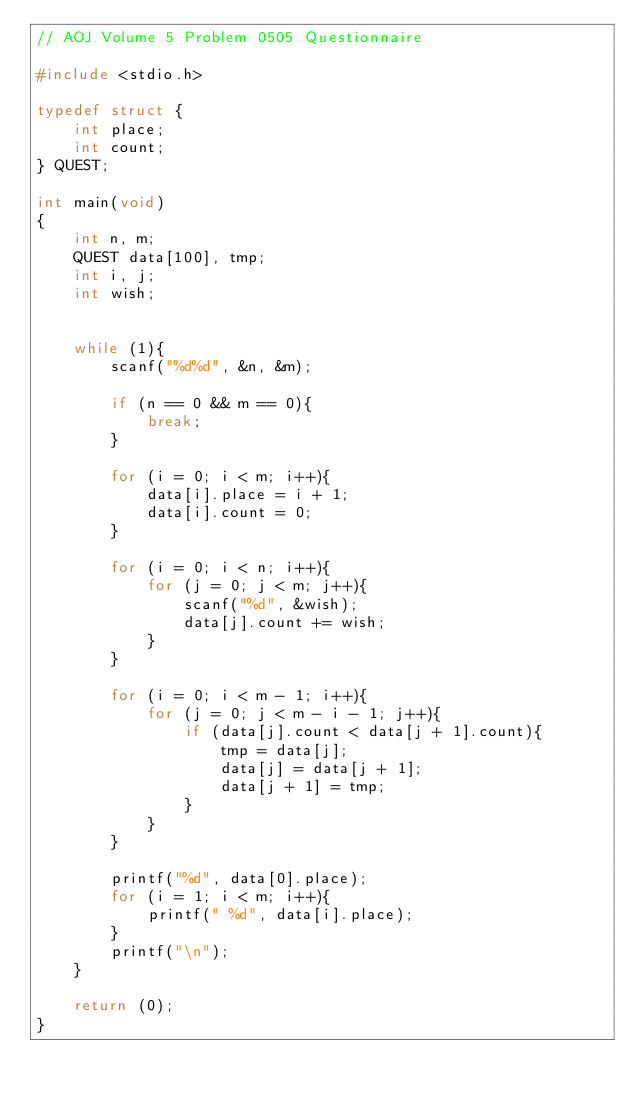Convert code to text. <code><loc_0><loc_0><loc_500><loc_500><_C_>// AOJ Volume 5 Problem 0505 Questionnaire

#include <stdio.h>

typedef struct {
    int place;
    int count;
} QUEST;

int main(void)
{
    int n, m;
    QUEST data[100], tmp;
    int i, j;
    int wish;

    
    while (1){
        scanf("%d%d", &n, &m);
        
        if (n == 0 && m == 0){
            break;
        }
        
        for (i = 0; i < m; i++){
            data[i].place = i + 1;
            data[i].count = 0;
        }
        
        for (i = 0; i < n; i++){
            for (j = 0; j < m; j++){
                scanf("%d", &wish);
                data[j].count += wish;
            }
        }
        
        for (i = 0; i < m - 1; i++){
            for (j = 0; j < m - i - 1; j++){
                if (data[j].count < data[j + 1].count){
                    tmp = data[j];
                    data[j] = data[j + 1];
                    data[j + 1] = tmp;
                }
            }
        }
        
        printf("%d", data[0].place);
        for (i = 1; i < m; i++){
            printf(" %d", data[i].place);
        }
        printf("\n");
    }
    
    return (0);
}</code> 